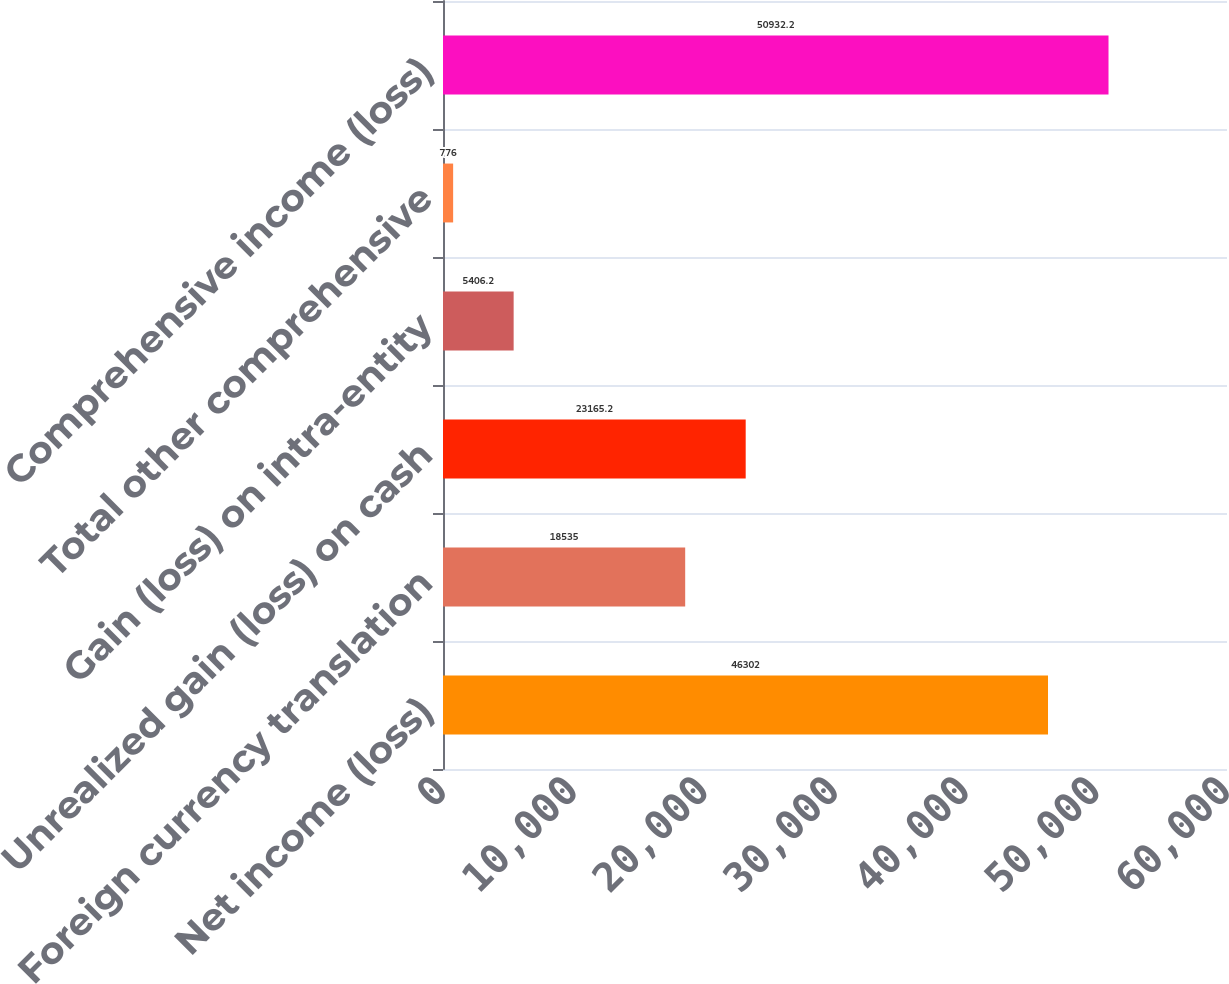Convert chart. <chart><loc_0><loc_0><loc_500><loc_500><bar_chart><fcel>Net income (loss)<fcel>Foreign currency translation<fcel>Unrealized gain (loss) on cash<fcel>Gain (loss) on intra-entity<fcel>Total other comprehensive<fcel>Comprehensive income (loss)<nl><fcel>46302<fcel>18535<fcel>23165.2<fcel>5406.2<fcel>776<fcel>50932.2<nl></chart> 